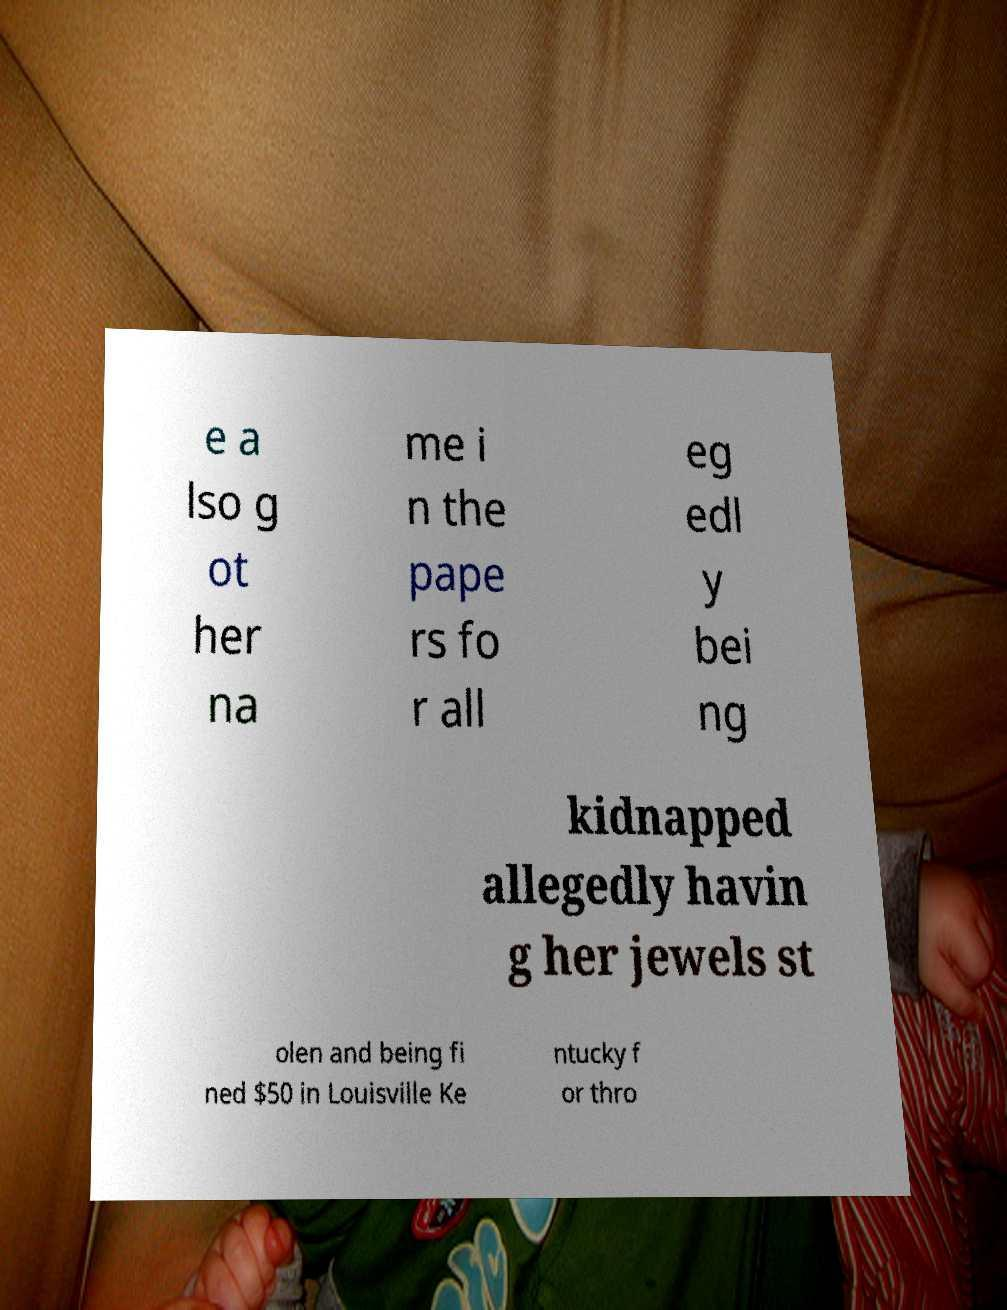Can you read and provide the text displayed in the image?This photo seems to have some interesting text. Can you extract and type it out for me? e a lso g ot her na me i n the pape rs fo r all eg edl y bei ng kidnapped allegedly havin g her jewels st olen and being fi ned $50 in Louisville Ke ntucky f or thro 